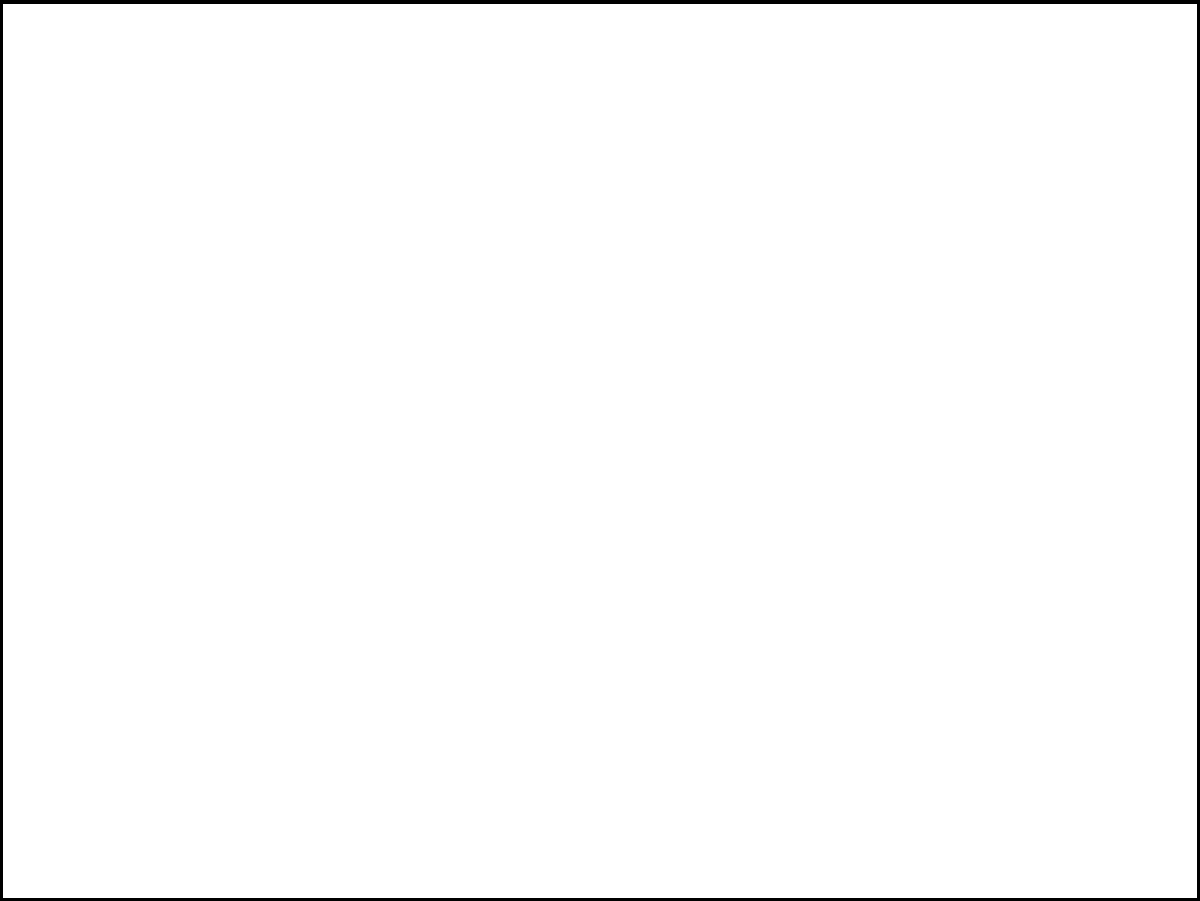Dado um retângulo ABCD no plano cartesiano com coordenadas A(1,1), B(5,1), C(5,4) e D(1,4), calcule a área deste retângulo. Para calcular a área do retângulo, precisamos encontrar seu comprimento e largura:

1. Comprimento (base):
   - Coordenada x de B menos coordenada x de A
   - $5 - 1 = 4$ unidades

2. Largura (altura):
   - Coordenada y de D menos coordenada y de A
   - $4 - 1 = 3$ unidades

3. Fórmula da área do retângulo:
   $A = base \times altura$

4. Substituindo os valores:
   $A = 4 \times 3 = 12$

Portanto, a área do retângulo é 12 unidades quadradas.
Answer: 12 unidades quadradas 